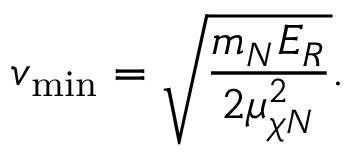Convert formula to latex. <formula><loc_0><loc_0><loc_500><loc_500>v _ { \min } = \sqrt { \frac { m _ { N } E _ { R } } { 2 \mu _ { \chi N } ^ { 2 } } } .</formula> 